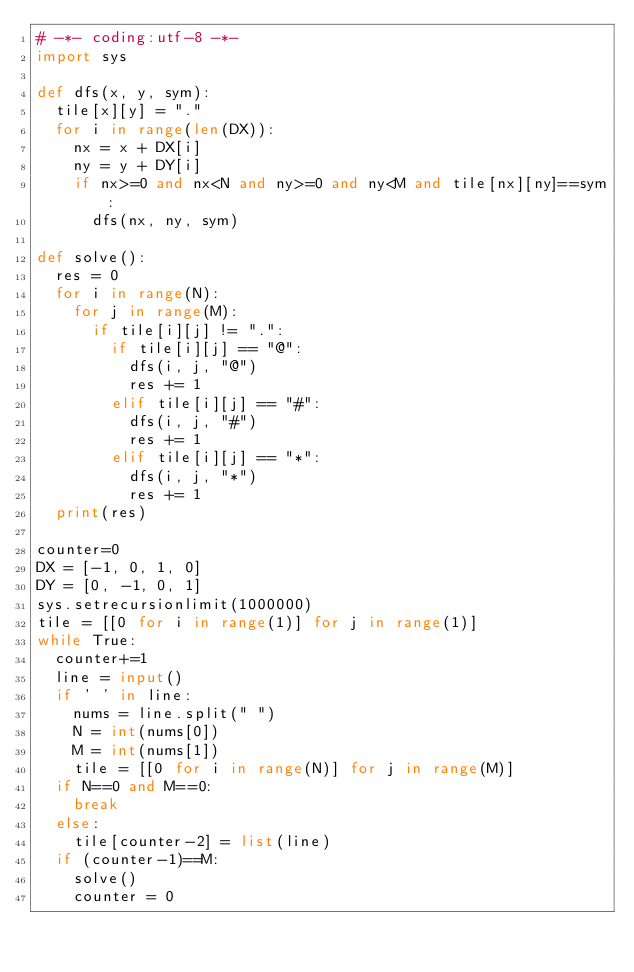Convert code to text. <code><loc_0><loc_0><loc_500><loc_500><_Python_># -*- coding:utf-8 -*-
import sys

def dfs(x, y, sym):
	tile[x][y] = "."
	for i in range(len(DX)):
		nx = x + DX[i]
		ny = y + DY[i]
		if nx>=0 and nx<N and ny>=0 and ny<M and tile[nx][ny]==sym:
			dfs(nx, ny, sym)

def solve():
	res = 0
	for i in range(N):
		for j in range(M):
			if tile[i][j] != ".":
				if tile[i][j] == "@":
					dfs(i, j, "@")
					res += 1
				elif tile[i][j] == "#":
					dfs(i, j, "#")
					res += 1
				elif tile[i][j] == "*":
					dfs(i, j, "*")
					res += 1
	print(res)

counter=0
DX = [-1, 0, 1, 0]
DY = [0, -1, 0, 1]
sys.setrecursionlimit(1000000)
tile = [[0 for i in range(1)] for j in range(1)]
while True:
	counter+=1
	line = input()
	if ' ' in line:
		nums = line.split(" ")
		N = int(nums[0])
		M = int(nums[1])
		tile = [[0 for i in range(N)] for j in range(M)]
	if N==0 and M==0:
		break
	else:
		tile[counter-2] = list(line)
	if (counter-1)==M:
		solve()
		counter = 0</code> 